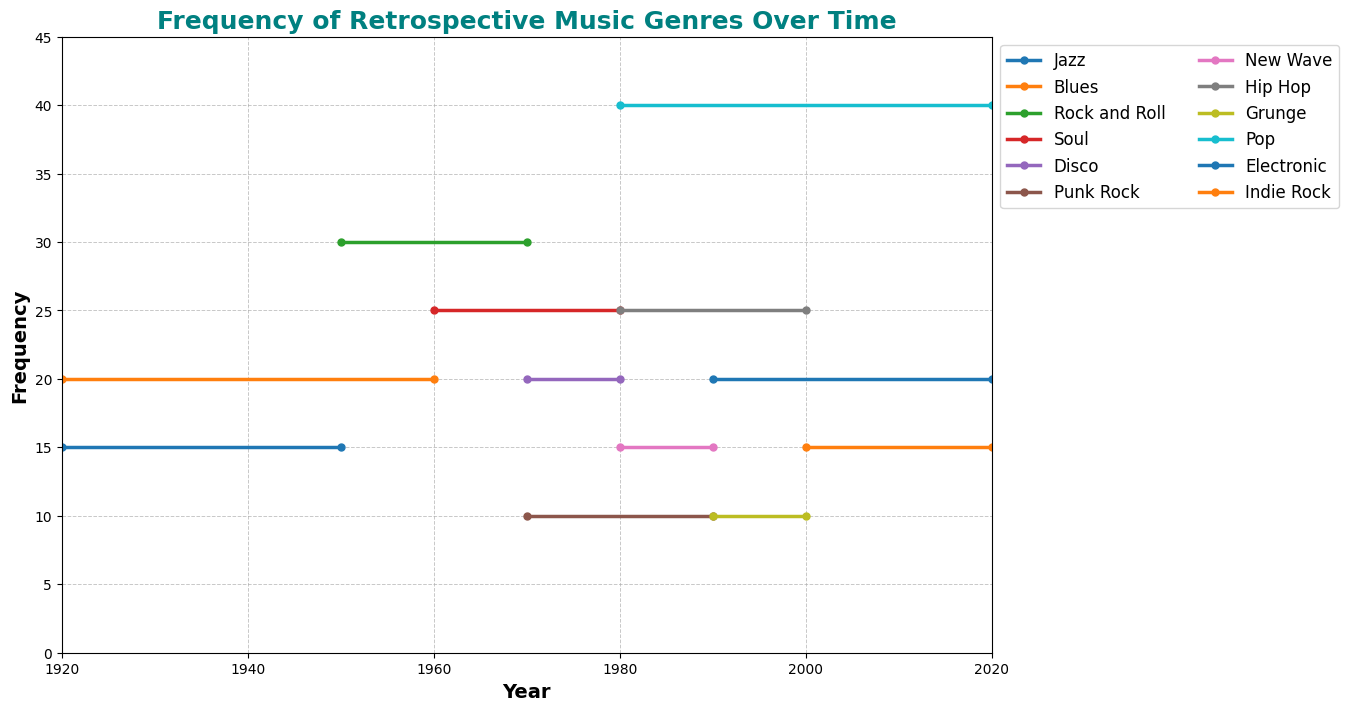Which genre had the highest frequency in the 1950s? By looking at the plot, identify the genre with the highest step during the 1950s period.
Answer: Rock and Roll Which two genres overlap in time during the 1980s, and what are their frequencies? Identify the genres that occupy time periods covering the 1980s. Scan for overlapping periods and note their respective frequencies.
Answer: New Wave (15) and Hip Hop (25) What's the combined frequency of Jazz and Blues in 1940? Find the frequencies of Jazz and Blues in the 1940s and sum them up. Jazz frequency is 15, and Blues frequency is 20.
Answer: 35 How did the frequency of Disco change in the 1980s? Identify the end year of Disco's frequency and observe if it continues or drops to zero by 1980. Disco frequency ends at 1980 and does not extend beyond that year.
Answer: It drops to zero Which two genres had the same frequency in the 2000s? Examine the frequency levels of the genres' steps that continue or start in the 2000s and check for matches. Both Indie Rock and Electronic have a frequency of 15.
Answer: Indie Rock and Electronic What is the difference in frequency between Soul and Punk Rock in the 1970s? Check the frequencies of Soul and Punk Rock during their time covering the 1970s. The frequency of Soul is 25, and Punk Rock is 10, then subtract Punk Rock from Soul.
Answer: 15 Which genre lasted the longest and what is the duration? Compare the lengths of the steps of each genre on the x-axis to identify the longest one. Blues lasted from 1920 to 1960, making it the longest. Calculate 1960 - 1920 = 40 years.
Answer: Blues, 40 years What can you infer from the plot about Pop music's frequency trend over time? Observe the plot for the continuous range and stability of Pop music's frequency from the starting year to the ending year. Pop frequency starts in 1980 and remains consistent at 40 until 2020.
Answer: Consistently high from 1980 to 2020 